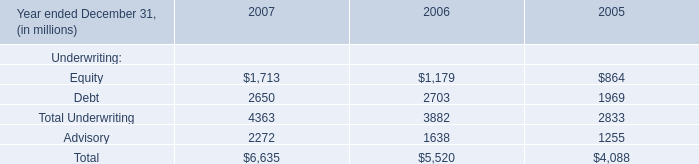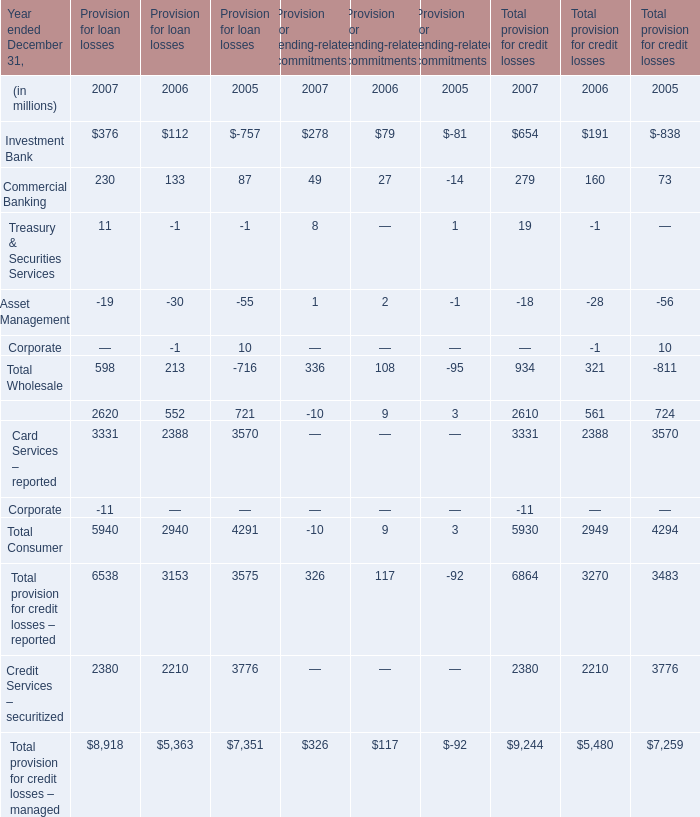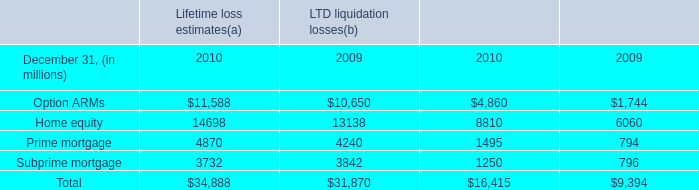what was the ratio of the business banking loans at december 31 , 2010 compared with $ 17.0 billion at december 31 , 2009 . 
Computations: (16.8 / 17.0)
Answer: 0.98824. 